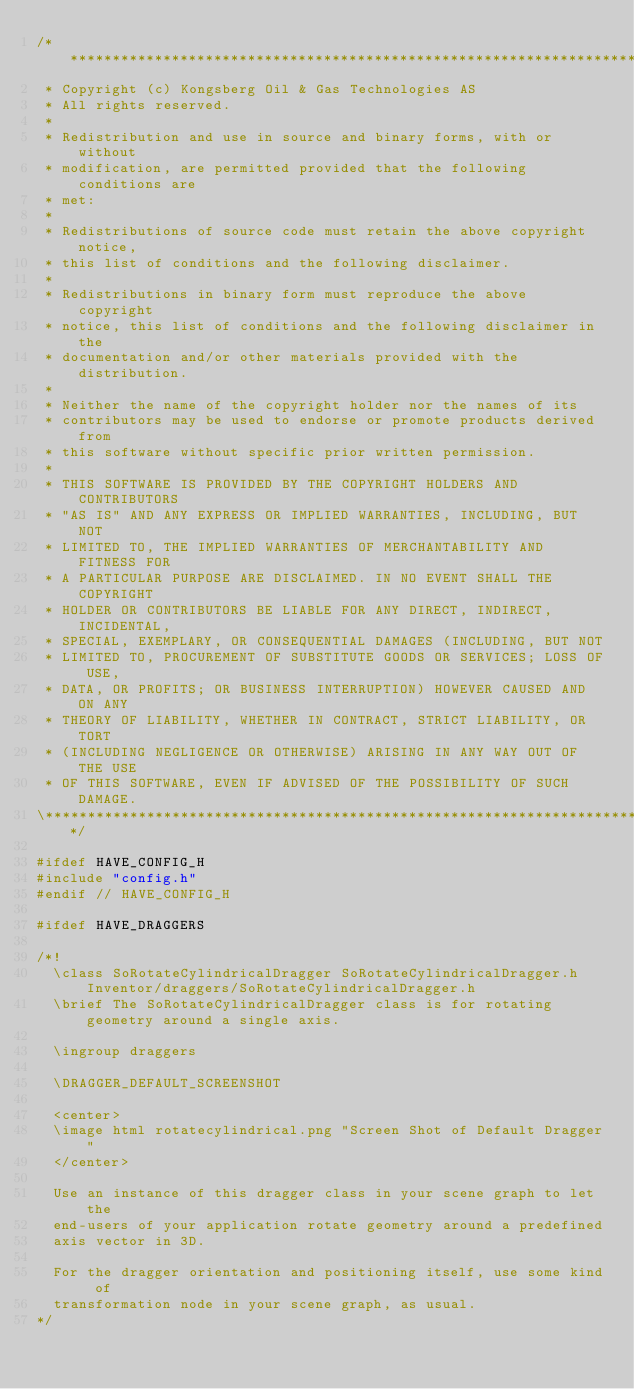Convert code to text. <code><loc_0><loc_0><loc_500><loc_500><_C++_>/**************************************************************************\
 * Copyright (c) Kongsberg Oil & Gas Technologies AS
 * All rights reserved.
 * 
 * Redistribution and use in source and binary forms, with or without
 * modification, are permitted provided that the following conditions are
 * met:
 * 
 * Redistributions of source code must retain the above copyright notice,
 * this list of conditions and the following disclaimer.
 * 
 * Redistributions in binary form must reproduce the above copyright
 * notice, this list of conditions and the following disclaimer in the
 * documentation and/or other materials provided with the distribution.
 * 
 * Neither the name of the copyright holder nor the names of its
 * contributors may be used to endorse or promote products derived from
 * this software without specific prior written permission.
 * 
 * THIS SOFTWARE IS PROVIDED BY THE COPYRIGHT HOLDERS AND CONTRIBUTORS
 * "AS IS" AND ANY EXPRESS OR IMPLIED WARRANTIES, INCLUDING, BUT NOT
 * LIMITED TO, THE IMPLIED WARRANTIES OF MERCHANTABILITY AND FITNESS FOR
 * A PARTICULAR PURPOSE ARE DISCLAIMED. IN NO EVENT SHALL THE COPYRIGHT
 * HOLDER OR CONTRIBUTORS BE LIABLE FOR ANY DIRECT, INDIRECT, INCIDENTAL,
 * SPECIAL, EXEMPLARY, OR CONSEQUENTIAL DAMAGES (INCLUDING, BUT NOT
 * LIMITED TO, PROCUREMENT OF SUBSTITUTE GOODS OR SERVICES; LOSS OF USE,
 * DATA, OR PROFITS; OR BUSINESS INTERRUPTION) HOWEVER CAUSED AND ON ANY
 * THEORY OF LIABILITY, WHETHER IN CONTRACT, STRICT LIABILITY, OR TORT
 * (INCLUDING NEGLIGENCE OR OTHERWISE) ARISING IN ANY WAY OUT OF THE USE
 * OF THIS SOFTWARE, EVEN IF ADVISED OF THE POSSIBILITY OF SUCH DAMAGE.
\**************************************************************************/

#ifdef HAVE_CONFIG_H
#include "config.h"
#endif // HAVE_CONFIG_H

#ifdef HAVE_DRAGGERS

/*!
  \class SoRotateCylindricalDragger SoRotateCylindricalDragger.h Inventor/draggers/SoRotateCylindricalDragger.h
  \brief The SoRotateCylindricalDragger class is for rotating geometry around a single axis.

  \ingroup draggers

  \DRAGGER_DEFAULT_SCREENSHOT

  <center>
  \image html rotatecylindrical.png "Screen Shot of Default Dragger"
  </center>

  Use an instance of this dragger class in your scene graph to let the
  end-users of your application rotate geometry around a predefined
  axis vector in 3D.

  For the dragger orientation and positioning itself, use some kind of
  transformation node in your scene graph, as usual.
*/
</code> 